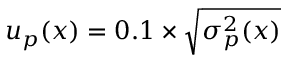Convert formula to latex. <formula><loc_0><loc_0><loc_500><loc_500>u _ { p } ( x ) = 0 . 1 \times \sqrt { \sigma _ { p } ^ { 2 } ( x ) }</formula> 